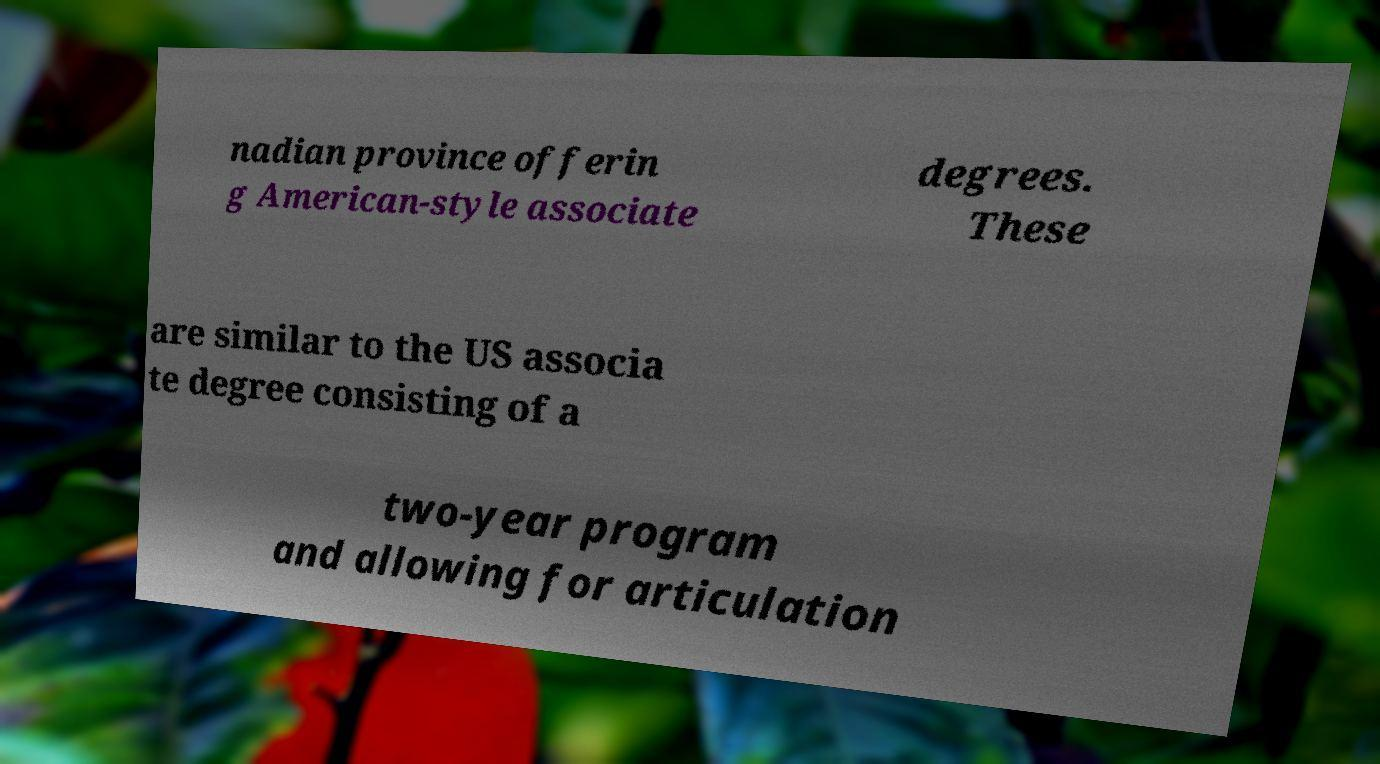Could you extract and type out the text from this image? nadian province offerin g American-style associate degrees. These are similar to the US associa te degree consisting of a two-year program and allowing for articulation 